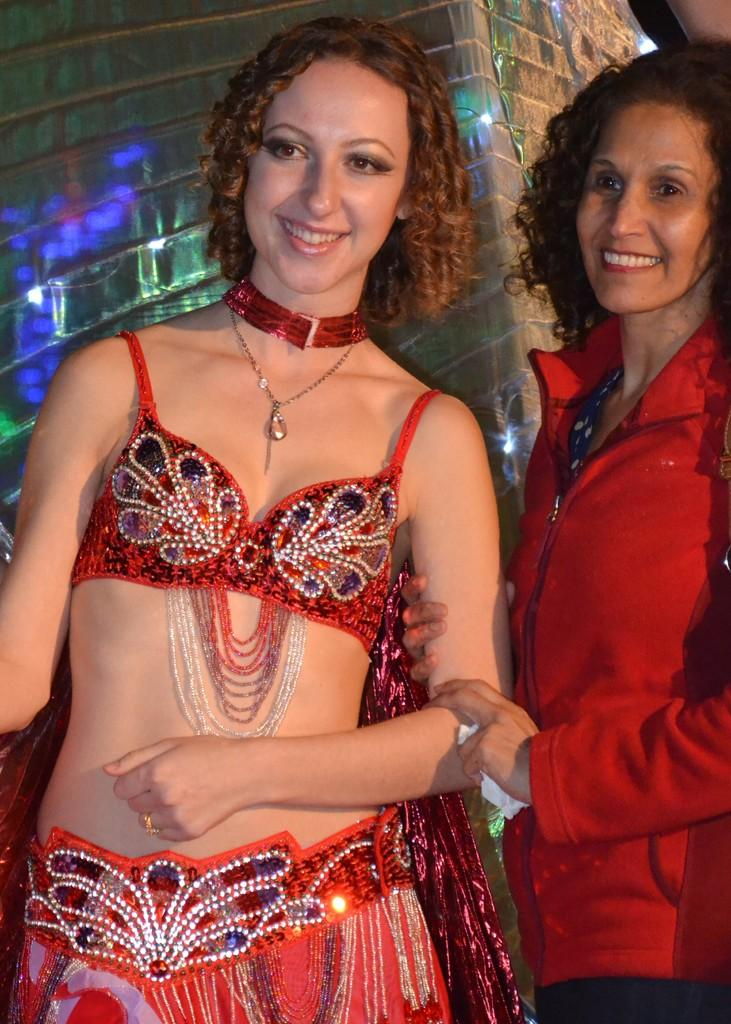How many people are in the image? There are two women in the image. What are the women doing in the image? The women are standing and smiling. What can be seen in the background of the image? There is a cover in the background of the image. How many toads are visible in the image? There are no toads present in the image. What type of lizards can be seen crawling on the women's shoulders in the image? There are no lizards present in the image. 